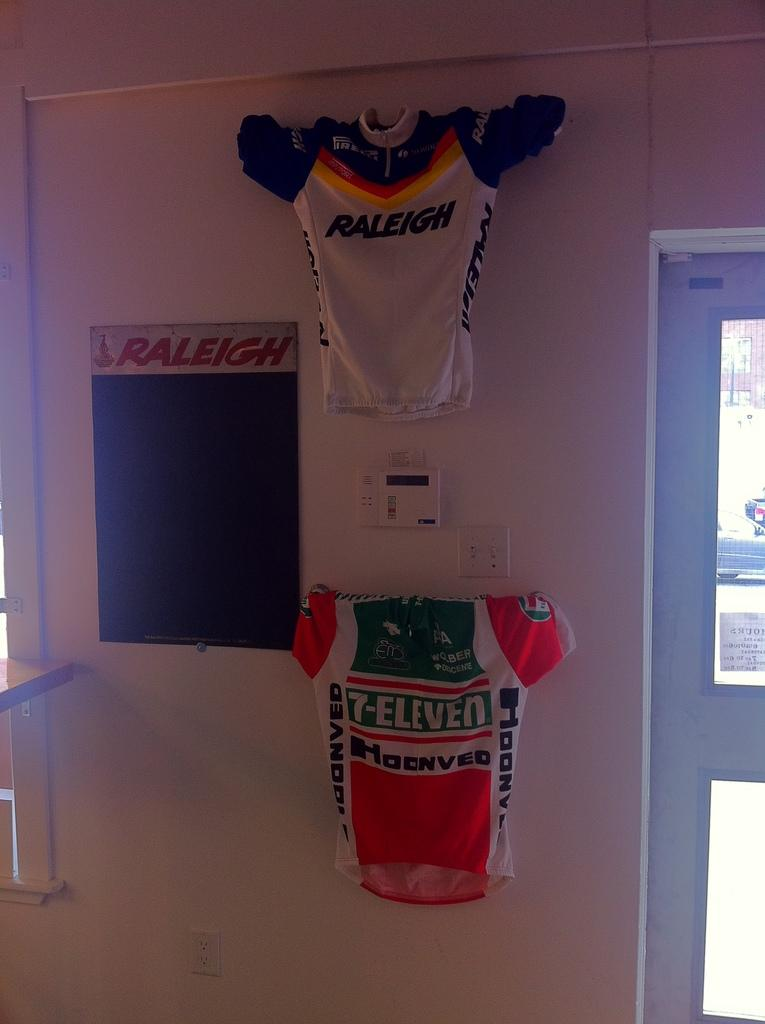<image>
Offer a succinct explanation of the picture presented. A 7-ELeven jersey is hanging on a wall under a Raleigh jersey. 